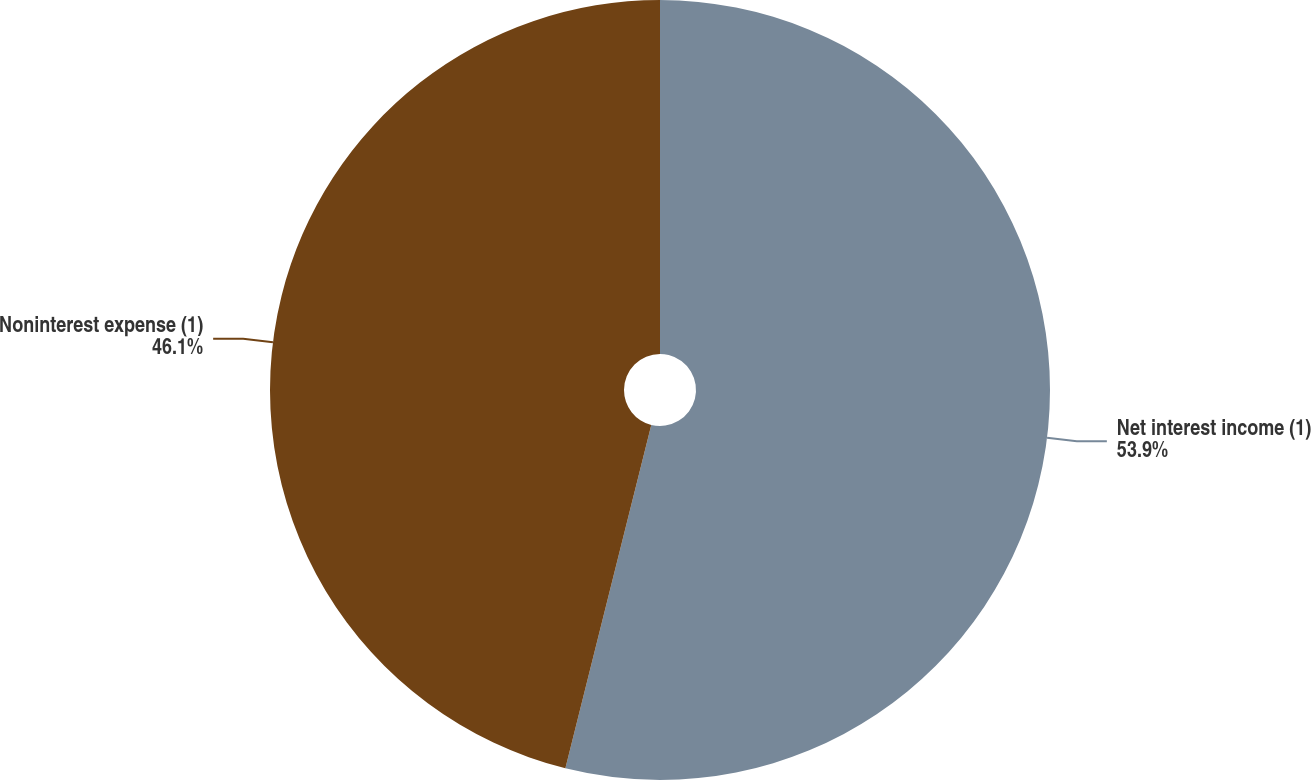<chart> <loc_0><loc_0><loc_500><loc_500><pie_chart><fcel>Net interest income (1)<fcel>Noninterest expense (1)<nl><fcel>53.9%<fcel>46.1%<nl></chart> 